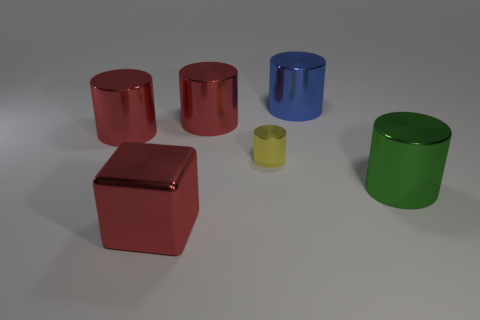Subtract all brown cubes. Subtract all yellow balls. How many cubes are left? 1 Subtract all blue cylinders. How many purple blocks are left? 0 Add 2 big things. How many large reds exist? 0 Subtract all big green cylinders. Subtract all big blue cylinders. How many objects are left? 4 Add 3 red metal cylinders. How many red metal cylinders are left? 5 Add 2 big red balls. How many big red balls exist? 2 Add 3 tiny green matte cubes. How many objects exist? 9 Subtract all red cylinders. How many cylinders are left? 3 Subtract all green shiny cylinders. How many cylinders are left? 4 Subtract 0 gray cubes. How many objects are left? 6 